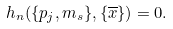Convert formula to latex. <formula><loc_0><loc_0><loc_500><loc_500>h _ { n } ( \{ p _ { j } , m _ { s } \} , \{ \overline { x } \} ) = 0 .</formula> 